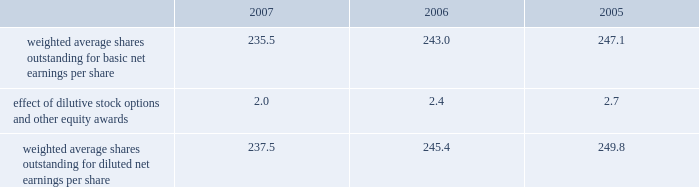Our tax returns are currently under examination in various foreign jurisdictions .
The major foreign tax jurisdictions under examination include germany , italy and switzerland .
It is reasonably possible that such audits will be resolved in the next twelve months , but we do not anticipate that the resolution of these audits would result in any material impact on our results of operations or financial position .
12 .
Capital stock and earnings per share we have 2 million shares of series a participating cumulative preferred stock authorized for issuance , none of which were outstanding as of december 31 , 2007 .
The numerator for both basic and diluted earnings per share is net earnings available to common stockholders .
The denominator for basic earnings per share is the weighted average number of common shares outstanding during the period .
The denominator for diluted earnings per share is weighted average shares outstanding adjusted for the effect of dilutive stock options and other equity awards .
The following is a reconciliation of weighted average shares for the basic and diluted share computations for the years ending december 31 ( in millions ) : .
Weighted average shares outstanding for basic net earnings per share 235.5 243.0 247.1 effect of dilutive stock options and other equity awards 2.0 2.4 2.7 weighted average shares outstanding for diluted net earnings per share 237.5 245.4 249.8 for the year ended december 31 , 2007 , an average of 3.1 million options to purchase shares of common stock were not included in the computation of diluted earnings per share as the exercise prices of these options were greater than the average market price of the common stock .
For the years ended december 31 , 2006 and 2005 , an average of 7.6 million and 2.9 million options , respectively , were not included .
In december 2005 , our board of directors authorized a stock repurchase program of up to $ 1 billion through december 31 , 2007 .
In december 2006 , our board of directors authorized an additional stock repurchase program of up to $ 1 billion through december 31 , 2008 .
As of december 31 , 2007 we had acquired approximately 19345200 shares at a cost of $ 1378.9 million , before commissions .
13 .
Segment data we design , develop , manufacture and market reconstructive orthopaedic implants , including joint and dental , spinal implants , trauma products and related orthopaedic surgical products which include surgical supplies and instruments designed to aid in orthopaedic surgical procedures and post-operation rehabilitation .
We also provide other healthcare related services .
Revenue related to these services currently represents less than 1 percent of our total net sales .
We manage operations through three major geographic segments 2013 the americas , which is comprised principally of the united states and includes other north , central and south american markets ; europe , which is comprised principally of europe and includes the middle east and africa ; and asia pacific , which is comprised primarily of japan and includes other asian and pacific markets .
This structure is the basis for our reportable segment information discussed below .
Management evaluates operating segment performance based upon segment operating profit exclusive of operating expenses pertaining to global operations and corporate expenses , share-based compensation expense , settlement , acquisition , integration and other expenses , inventory step-up , in-process research and development write- offs and intangible asset amortization expense .
Global operations include research , development engineering , medical education , brand management , corporate legal , finance , and human resource functions , and u.s .
And puerto rico based manufacturing operations and logistics .
Intercompany transactions have been eliminated from segment operating profit .
Management reviews accounts receivable , inventory , property , plant and equipment , goodwill and intangible assets by reportable segment exclusive of u.s and puerto rico based manufacturing operations and logistics and corporate assets .
Z i m m e r h o l d i n g s , i n c .
2 0 0 7 f o r m 1 0 - k a n n u a l r e p o r t notes to consolidated financial statements ( continued ) .
What is the change in weighted average shares outstanding for diluted net earnings per share between 2006 and 2007 , in millions? 
Computations: (237.5 - 245.4)
Answer: -7.9. 